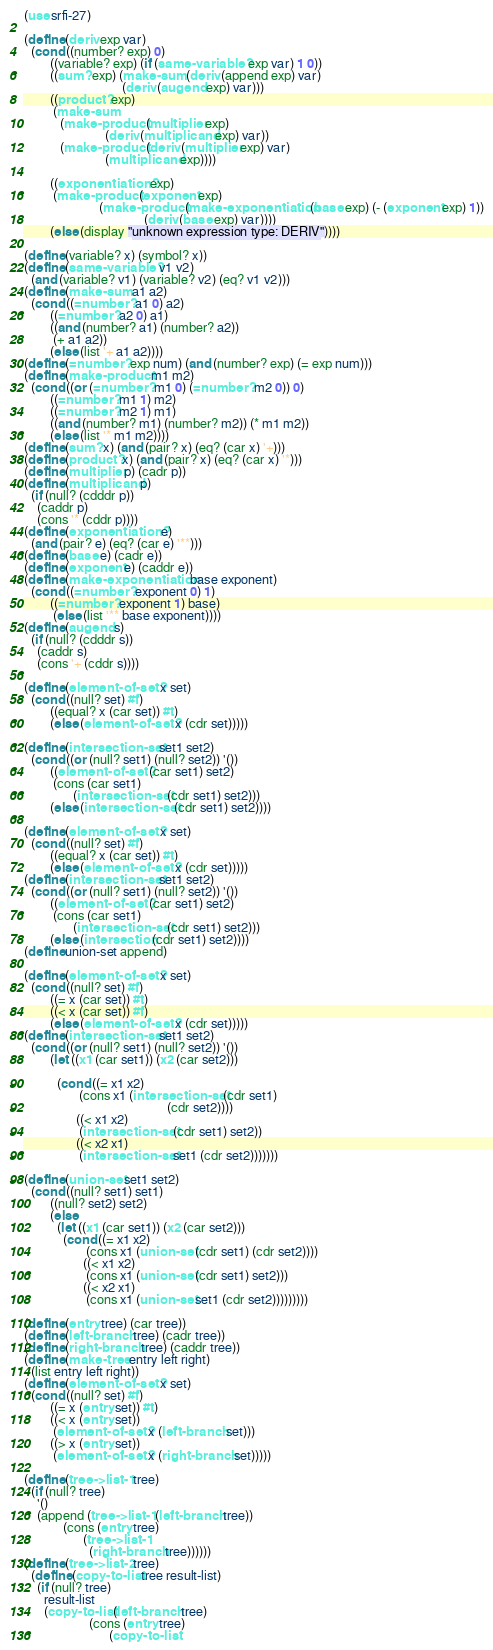<code> <loc_0><loc_0><loc_500><loc_500><_Scheme_>(use srfi-27)

(define (deriv exp var)
  (cond ((number? exp) 0)
		((variable? exp) (if (same-variable? exp var) 1 0))
		((sum? exp) (make-sum (deriv (append exp) var)
							  (deriv (augend exp) var)))
		((product? exp)
		 (make-sum
		   (make-product (multiplier exp)
						 (deriv (multiplicand exp) var))
		   (make-product (deriv (multiplier exp) var)
						 (multiplicand exp))))
	
		((exponentiation? exp)
		 (make-product (exponent exp)
					   (make-product (make-exponentiation (base exp) (- (exponent exp) 1))
									 (deriv (base exp) var))))
		(else (display "unknown expression type: DERIV"))))

(define (variable? x) (symbol? x))
(define (same-variable? v1 v2)
  (and (variable? v1) (variable? v2) (eq? v1 v2)))
(define (make-sum a1 a2)
  (cond ((=number? a1 0) a2)
		((=number? a2 0) a1)
		((and (number? a1) (number? a2))
		 (+ a1 a2))
		(else (list '+ a1 a2))))
(define (=number? exp num) (and (number? exp) (= exp num)))
(define (make-product m1 m2)
  (cond ((or (=number? m1 0) (=number? m2 0)) 0)
		((=number? m1 1) m2)
		((=number? m2 1) m1)
		((and (number? m1) (number? m2)) (* m1 m2))
		(else (list '* m1 m2))))
(define (sum? x) (and (pair? x) (eq? (car x) '+)))
(define (product? x) (and (pair? x) (eq? (car x) '*)))
(define (multiplier p) (cadr p))
(define (multiplicand p)
  (if (null? (cdddr p))
	(caddr p)
	(cons '* (cddr p))))
(define (exponentiation? e)
  (and (pair? e) (eq? (car e) '**)))
(define (base e) (cadr e))
(define (exponent e) (caddr e))
(define (make-exponentiation base exponent)
  (cond ((=number? exponent 0) 1)
		((=number? exponent 1) base)
		 (else (list '** base exponent))))
(define (augend s)
  (if (null? (cdddr s))
	(caddr s)
	(cons '+ (cddr s))))

(define (element-of-set? x set)
  (cond ((null? set) #f)
		((equal? x (car set)) #t)
		(else (element-of-set? x (cdr set)))))

(define (intersection-set set1 set2)
  (cond ((or (null? set1) (null? set2)) '())
		((element-of-set? (car set1) set2)
		 (cons (car set1)
			   (intersection-set (cdr set1) set2)))
		(else (intersection-set (cdr set1) set2))))

(define (element-of-set? x set)
  (cond ((null? set) #f)
		((equal? x (car set)) #t)
		(else (element-of-set? x (cdr set)))))
(define (intersection-set set1 set2)
  (cond ((or (null? set1) (null? set2)) '())
		((element-of-set? (car set1) set2)
		 (cons (car set1)
			   (intersection-set (cdr set1) set2)))
		(else (intersection (cdr set1) set2))))
(define union-set append)

(define (element-of-set? x set)
  (cond ((null? set) #f)
		((= x (car set)) #t)
		((< x (car set)) #f)
		(else (element-of-set? x (cdr set)))))
(define (intersection-set set1 set2)
  (cond ((or (null? set1) (null? set2)) '())
		(let ((x1 (car set1)) (x2 (car set2)))
	
		  (cond ((= x1 x2)
				 (cons x1 (intersection-set (cdr set1)
											(cdr set2))))
				((< x1 x2)
				 (intersection-set (cdr set1) set2))
				((< x2 x1)
				 (intersection-set set1 (cdr set2)))))))

(define (union-set set1 set2)
  (cond ((null? set1) set1)
		((null? set2) set2)
		(else 
		  (let ((x1 (car set1)) (x2 (car set2)))
			(cond ((= x1 x2)
				   (cons x1 (union-set (cdr set1) (cdr set2))))
				  ((< x1 x2)
				   (cons x1 (union-set (cdr set1) set2)))
				  ((< x2 x1)
				   (cons x1 (union-set set1 (cdr set2)))))))))

(define (entry tree) (car tree))
(define (left-branch tree) (cadr tree))
(define (right-branch tree) (caddr tree))
(define (make-tree entry left right)
  (list entry left right))
(define (element-of-set? x set)
  (cond ((null? set) #f)
		((= x (entry set)) #t)
		((< x (entry set))
		 (element-of-set? x (left-branch set)))
		((> x (entry set))
		 (element-of-set? x (right-branch set)))))

(define (tree->list-1 tree)
  (if (null? tree)
	'()
	(append (tree->list-1 (left-branch tree))
			(cons (entry tree)
				  (tree->list-1
					(right-branch tree))))))
(define (tree->list-2 tree)
  (define (copy-to-list tree result-list)
	(if (null? tree)
	  result-list
	  (copy-to-list (left-branch tree)
					(cons (entry tree)
						  (copy-to-list</code> 